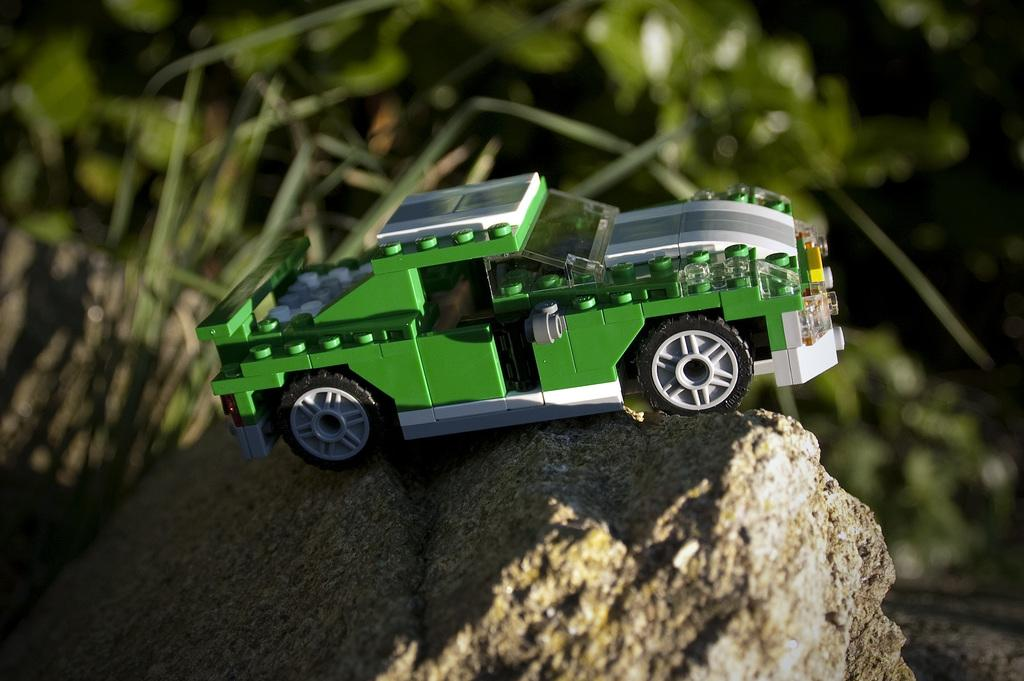What is the main subject of the picture? The main subject of the picture is a Lego vehicle. Where is the Lego vehicle located? The Lego vehicle is on a rock. Can you describe the background of the image? The background of the image is blurred. What type of property does the Lego vehicle own in the image? There is no indication of property ownership in the image, as it features a Lego vehicle on a rock. How many times does the frame of the image rotate during the scene? There is no frame present in the image, as it is a still photograph. 